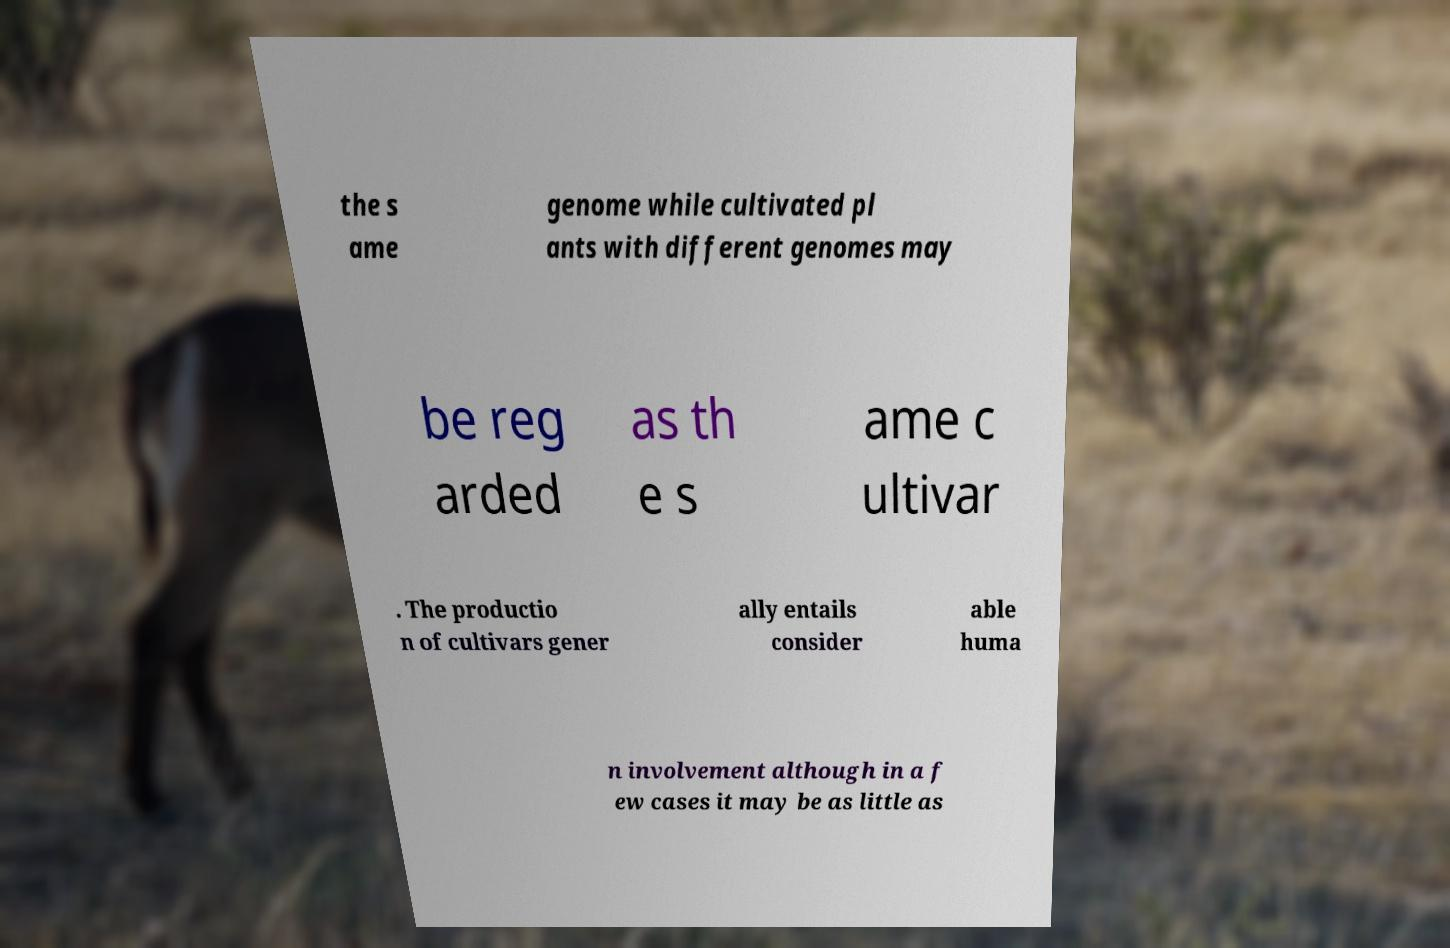For documentation purposes, I need the text within this image transcribed. Could you provide that? the s ame genome while cultivated pl ants with different genomes may be reg arded as th e s ame c ultivar . The productio n of cultivars gener ally entails consider able huma n involvement although in a f ew cases it may be as little as 